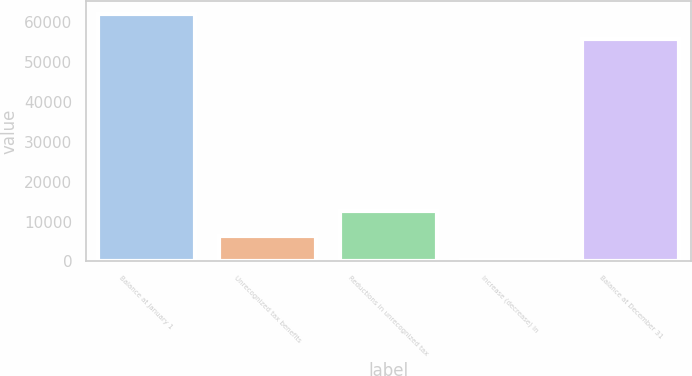<chart> <loc_0><loc_0><loc_500><loc_500><bar_chart><fcel>Balance at January 1<fcel>Unrecognized tax benefits<fcel>Reductions in unrecognized tax<fcel>Increase (decrease) in<fcel>Balance at December 31<nl><fcel>62108<fcel>6443<fcel>12628<fcel>258<fcel>55771<nl></chart> 